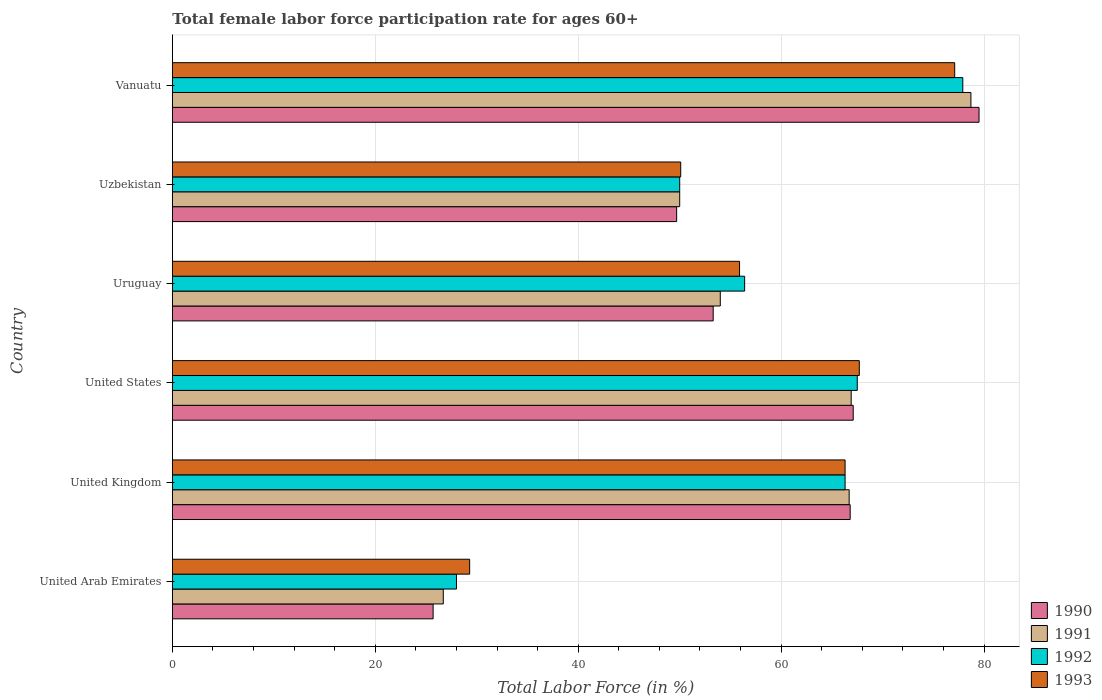How many different coloured bars are there?
Provide a short and direct response. 4. How many bars are there on the 6th tick from the top?
Your answer should be compact. 4. What is the label of the 3rd group of bars from the top?
Offer a very short reply. Uruguay. What is the female labor force participation rate in 1990 in United Arab Emirates?
Your response must be concise. 25.7. Across all countries, what is the maximum female labor force participation rate in 1992?
Your answer should be compact. 77.9. Across all countries, what is the minimum female labor force participation rate in 1991?
Offer a very short reply. 26.7. In which country was the female labor force participation rate in 1992 maximum?
Provide a short and direct response. Vanuatu. In which country was the female labor force participation rate in 1990 minimum?
Offer a terse response. United Arab Emirates. What is the total female labor force participation rate in 1992 in the graph?
Keep it short and to the point. 346.1. What is the difference between the female labor force participation rate in 1990 in United Arab Emirates and that in Vanuatu?
Your answer should be very brief. -53.8. What is the difference between the female labor force participation rate in 1990 in United States and the female labor force participation rate in 1993 in United Arab Emirates?
Your response must be concise. 37.8. What is the average female labor force participation rate in 1991 per country?
Offer a terse response. 57.17. What is the difference between the female labor force participation rate in 1990 and female labor force participation rate in 1993 in Uzbekistan?
Your response must be concise. -0.4. In how many countries, is the female labor force participation rate in 1991 greater than 24 %?
Offer a terse response. 6. What is the ratio of the female labor force participation rate in 1993 in United States to that in Uzbekistan?
Give a very brief answer. 1.35. Is the female labor force participation rate in 1993 in United Kingdom less than that in United States?
Give a very brief answer. Yes. Is the difference between the female labor force participation rate in 1990 in United Arab Emirates and Uzbekistan greater than the difference between the female labor force participation rate in 1993 in United Arab Emirates and Uzbekistan?
Make the answer very short. No. What is the difference between the highest and the second highest female labor force participation rate in 1991?
Ensure brevity in your answer.  11.8. What is the difference between the highest and the lowest female labor force participation rate in 1991?
Keep it short and to the point. 52. In how many countries, is the female labor force participation rate in 1993 greater than the average female labor force participation rate in 1993 taken over all countries?
Your response must be concise. 3. Is it the case that in every country, the sum of the female labor force participation rate in 1992 and female labor force participation rate in 1990 is greater than the sum of female labor force participation rate in 1993 and female labor force participation rate in 1991?
Your answer should be very brief. No. How many bars are there?
Make the answer very short. 24. How many countries are there in the graph?
Give a very brief answer. 6. What is the difference between two consecutive major ticks on the X-axis?
Your answer should be compact. 20. Does the graph contain any zero values?
Provide a short and direct response. No. Where does the legend appear in the graph?
Your response must be concise. Bottom right. How many legend labels are there?
Offer a terse response. 4. What is the title of the graph?
Your response must be concise. Total female labor force participation rate for ages 60+. What is the label or title of the X-axis?
Your answer should be compact. Total Labor Force (in %). What is the label or title of the Y-axis?
Give a very brief answer. Country. What is the Total Labor Force (in %) of 1990 in United Arab Emirates?
Your response must be concise. 25.7. What is the Total Labor Force (in %) of 1991 in United Arab Emirates?
Offer a terse response. 26.7. What is the Total Labor Force (in %) in 1993 in United Arab Emirates?
Your response must be concise. 29.3. What is the Total Labor Force (in %) of 1990 in United Kingdom?
Ensure brevity in your answer.  66.8. What is the Total Labor Force (in %) of 1991 in United Kingdom?
Keep it short and to the point. 66.7. What is the Total Labor Force (in %) of 1992 in United Kingdom?
Keep it short and to the point. 66.3. What is the Total Labor Force (in %) in 1993 in United Kingdom?
Give a very brief answer. 66.3. What is the Total Labor Force (in %) in 1990 in United States?
Provide a short and direct response. 67.1. What is the Total Labor Force (in %) in 1991 in United States?
Your answer should be very brief. 66.9. What is the Total Labor Force (in %) of 1992 in United States?
Ensure brevity in your answer.  67.5. What is the Total Labor Force (in %) of 1993 in United States?
Give a very brief answer. 67.7. What is the Total Labor Force (in %) in 1990 in Uruguay?
Keep it short and to the point. 53.3. What is the Total Labor Force (in %) in 1991 in Uruguay?
Make the answer very short. 54. What is the Total Labor Force (in %) of 1992 in Uruguay?
Provide a short and direct response. 56.4. What is the Total Labor Force (in %) in 1993 in Uruguay?
Your response must be concise. 55.9. What is the Total Labor Force (in %) of 1990 in Uzbekistan?
Provide a succinct answer. 49.7. What is the Total Labor Force (in %) in 1991 in Uzbekistan?
Your response must be concise. 50. What is the Total Labor Force (in %) of 1993 in Uzbekistan?
Give a very brief answer. 50.1. What is the Total Labor Force (in %) of 1990 in Vanuatu?
Ensure brevity in your answer.  79.5. What is the Total Labor Force (in %) of 1991 in Vanuatu?
Give a very brief answer. 78.7. What is the Total Labor Force (in %) of 1992 in Vanuatu?
Your answer should be very brief. 77.9. What is the Total Labor Force (in %) in 1993 in Vanuatu?
Ensure brevity in your answer.  77.1. Across all countries, what is the maximum Total Labor Force (in %) of 1990?
Provide a succinct answer. 79.5. Across all countries, what is the maximum Total Labor Force (in %) in 1991?
Offer a very short reply. 78.7. Across all countries, what is the maximum Total Labor Force (in %) in 1992?
Keep it short and to the point. 77.9. Across all countries, what is the maximum Total Labor Force (in %) in 1993?
Provide a succinct answer. 77.1. Across all countries, what is the minimum Total Labor Force (in %) of 1990?
Make the answer very short. 25.7. Across all countries, what is the minimum Total Labor Force (in %) of 1991?
Your answer should be very brief. 26.7. Across all countries, what is the minimum Total Labor Force (in %) in 1993?
Offer a terse response. 29.3. What is the total Total Labor Force (in %) of 1990 in the graph?
Provide a short and direct response. 342.1. What is the total Total Labor Force (in %) of 1991 in the graph?
Your response must be concise. 343. What is the total Total Labor Force (in %) in 1992 in the graph?
Your answer should be very brief. 346.1. What is the total Total Labor Force (in %) of 1993 in the graph?
Provide a succinct answer. 346.4. What is the difference between the Total Labor Force (in %) in 1990 in United Arab Emirates and that in United Kingdom?
Your answer should be compact. -41.1. What is the difference between the Total Labor Force (in %) in 1991 in United Arab Emirates and that in United Kingdom?
Provide a short and direct response. -40. What is the difference between the Total Labor Force (in %) of 1992 in United Arab Emirates and that in United Kingdom?
Offer a terse response. -38.3. What is the difference between the Total Labor Force (in %) in 1993 in United Arab Emirates and that in United Kingdom?
Give a very brief answer. -37. What is the difference between the Total Labor Force (in %) in 1990 in United Arab Emirates and that in United States?
Keep it short and to the point. -41.4. What is the difference between the Total Labor Force (in %) in 1991 in United Arab Emirates and that in United States?
Offer a very short reply. -40.2. What is the difference between the Total Labor Force (in %) in 1992 in United Arab Emirates and that in United States?
Your response must be concise. -39.5. What is the difference between the Total Labor Force (in %) in 1993 in United Arab Emirates and that in United States?
Offer a very short reply. -38.4. What is the difference between the Total Labor Force (in %) of 1990 in United Arab Emirates and that in Uruguay?
Your answer should be very brief. -27.6. What is the difference between the Total Labor Force (in %) in 1991 in United Arab Emirates and that in Uruguay?
Ensure brevity in your answer.  -27.3. What is the difference between the Total Labor Force (in %) of 1992 in United Arab Emirates and that in Uruguay?
Ensure brevity in your answer.  -28.4. What is the difference between the Total Labor Force (in %) in 1993 in United Arab Emirates and that in Uruguay?
Make the answer very short. -26.6. What is the difference between the Total Labor Force (in %) in 1991 in United Arab Emirates and that in Uzbekistan?
Your response must be concise. -23.3. What is the difference between the Total Labor Force (in %) of 1993 in United Arab Emirates and that in Uzbekistan?
Your answer should be very brief. -20.8. What is the difference between the Total Labor Force (in %) in 1990 in United Arab Emirates and that in Vanuatu?
Make the answer very short. -53.8. What is the difference between the Total Labor Force (in %) in 1991 in United Arab Emirates and that in Vanuatu?
Your answer should be compact. -52. What is the difference between the Total Labor Force (in %) in 1992 in United Arab Emirates and that in Vanuatu?
Your answer should be very brief. -49.9. What is the difference between the Total Labor Force (in %) of 1993 in United Arab Emirates and that in Vanuatu?
Offer a terse response. -47.8. What is the difference between the Total Labor Force (in %) of 1990 in United Kingdom and that in United States?
Your answer should be compact. -0.3. What is the difference between the Total Labor Force (in %) in 1992 in United Kingdom and that in United States?
Ensure brevity in your answer.  -1.2. What is the difference between the Total Labor Force (in %) in 1993 in United Kingdom and that in United States?
Provide a succinct answer. -1.4. What is the difference between the Total Labor Force (in %) of 1990 in United Kingdom and that in Uruguay?
Make the answer very short. 13.5. What is the difference between the Total Labor Force (in %) of 1991 in United Kingdom and that in Uruguay?
Make the answer very short. 12.7. What is the difference between the Total Labor Force (in %) of 1992 in United Kingdom and that in Uruguay?
Your answer should be very brief. 9.9. What is the difference between the Total Labor Force (in %) of 1993 in United Kingdom and that in Uruguay?
Your answer should be compact. 10.4. What is the difference between the Total Labor Force (in %) of 1990 in United Kingdom and that in Uzbekistan?
Provide a succinct answer. 17.1. What is the difference between the Total Labor Force (in %) in 1991 in United Kingdom and that in Uzbekistan?
Your answer should be compact. 16.7. What is the difference between the Total Labor Force (in %) in 1992 in United Kingdom and that in Uzbekistan?
Give a very brief answer. 16.3. What is the difference between the Total Labor Force (in %) in 1993 in United Kingdom and that in Uzbekistan?
Your answer should be compact. 16.2. What is the difference between the Total Labor Force (in %) of 1991 in United Kingdom and that in Vanuatu?
Ensure brevity in your answer.  -12. What is the difference between the Total Labor Force (in %) in 1992 in United Kingdom and that in Vanuatu?
Offer a terse response. -11.6. What is the difference between the Total Labor Force (in %) in 1991 in United States and that in Uruguay?
Your answer should be very brief. 12.9. What is the difference between the Total Labor Force (in %) in 1990 in United States and that in Uzbekistan?
Offer a very short reply. 17.4. What is the difference between the Total Labor Force (in %) of 1992 in United States and that in Uzbekistan?
Provide a short and direct response. 17.5. What is the difference between the Total Labor Force (in %) of 1993 in United States and that in Vanuatu?
Provide a succinct answer. -9.4. What is the difference between the Total Labor Force (in %) in 1991 in Uruguay and that in Uzbekistan?
Give a very brief answer. 4. What is the difference between the Total Labor Force (in %) in 1990 in Uruguay and that in Vanuatu?
Provide a short and direct response. -26.2. What is the difference between the Total Labor Force (in %) in 1991 in Uruguay and that in Vanuatu?
Provide a short and direct response. -24.7. What is the difference between the Total Labor Force (in %) in 1992 in Uruguay and that in Vanuatu?
Your answer should be compact. -21.5. What is the difference between the Total Labor Force (in %) of 1993 in Uruguay and that in Vanuatu?
Ensure brevity in your answer.  -21.2. What is the difference between the Total Labor Force (in %) of 1990 in Uzbekistan and that in Vanuatu?
Provide a short and direct response. -29.8. What is the difference between the Total Labor Force (in %) in 1991 in Uzbekistan and that in Vanuatu?
Make the answer very short. -28.7. What is the difference between the Total Labor Force (in %) in 1992 in Uzbekistan and that in Vanuatu?
Your response must be concise. -27.9. What is the difference between the Total Labor Force (in %) of 1993 in Uzbekistan and that in Vanuatu?
Ensure brevity in your answer.  -27. What is the difference between the Total Labor Force (in %) in 1990 in United Arab Emirates and the Total Labor Force (in %) in 1991 in United Kingdom?
Your response must be concise. -41. What is the difference between the Total Labor Force (in %) in 1990 in United Arab Emirates and the Total Labor Force (in %) in 1992 in United Kingdom?
Your response must be concise. -40.6. What is the difference between the Total Labor Force (in %) in 1990 in United Arab Emirates and the Total Labor Force (in %) in 1993 in United Kingdom?
Give a very brief answer. -40.6. What is the difference between the Total Labor Force (in %) of 1991 in United Arab Emirates and the Total Labor Force (in %) of 1992 in United Kingdom?
Offer a terse response. -39.6. What is the difference between the Total Labor Force (in %) in 1991 in United Arab Emirates and the Total Labor Force (in %) in 1993 in United Kingdom?
Offer a very short reply. -39.6. What is the difference between the Total Labor Force (in %) of 1992 in United Arab Emirates and the Total Labor Force (in %) of 1993 in United Kingdom?
Ensure brevity in your answer.  -38.3. What is the difference between the Total Labor Force (in %) in 1990 in United Arab Emirates and the Total Labor Force (in %) in 1991 in United States?
Offer a terse response. -41.2. What is the difference between the Total Labor Force (in %) of 1990 in United Arab Emirates and the Total Labor Force (in %) of 1992 in United States?
Ensure brevity in your answer.  -41.8. What is the difference between the Total Labor Force (in %) in 1990 in United Arab Emirates and the Total Labor Force (in %) in 1993 in United States?
Your answer should be very brief. -42. What is the difference between the Total Labor Force (in %) in 1991 in United Arab Emirates and the Total Labor Force (in %) in 1992 in United States?
Offer a terse response. -40.8. What is the difference between the Total Labor Force (in %) in 1991 in United Arab Emirates and the Total Labor Force (in %) in 1993 in United States?
Your answer should be compact. -41. What is the difference between the Total Labor Force (in %) of 1992 in United Arab Emirates and the Total Labor Force (in %) of 1993 in United States?
Your answer should be compact. -39.7. What is the difference between the Total Labor Force (in %) of 1990 in United Arab Emirates and the Total Labor Force (in %) of 1991 in Uruguay?
Make the answer very short. -28.3. What is the difference between the Total Labor Force (in %) of 1990 in United Arab Emirates and the Total Labor Force (in %) of 1992 in Uruguay?
Your response must be concise. -30.7. What is the difference between the Total Labor Force (in %) in 1990 in United Arab Emirates and the Total Labor Force (in %) in 1993 in Uruguay?
Your answer should be very brief. -30.2. What is the difference between the Total Labor Force (in %) in 1991 in United Arab Emirates and the Total Labor Force (in %) in 1992 in Uruguay?
Provide a succinct answer. -29.7. What is the difference between the Total Labor Force (in %) of 1991 in United Arab Emirates and the Total Labor Force (in %) of 1993 in Uruguay?
Give a very brief answer. -29.2. What is the difference between the Total Labor Force (in %) in 1992 in United Arab Emirates and the Total Labor Force (in %) in 1993 in Uruguay?
Provide a succinct answer. -27.9. What is the difference between the Total Labor Force (in %) of 1990 in United Arab Emirates and the Total Labor Force (in %) of 1991 in Uzbekistan?
Provide a succinct answer. -24.3. What is the difference between the Total Labor Force (in %) in 1990 in United Arab Emirates and the Total Labor Force (in %) in 1992 in Uzbekistan?
Your answer should be very brief. -24.3. What is the difference between the Total Labor Force (in %) of 1990 in United Arab Emirates and the Total Labor Force (in %) of 1993 in Uzbekistan?
Provide a succinct answer. -24.4. What is the difference between the Total Labor Force (in %) of 1991 in United Arab Emirates and the Total Labor Force (in %) of 1992 in Uzbekistan?
Your answer should be compact. -23.3. What is the difference between the Total Labor Force (in %) in 1991 in United Arab Emirates and the Total Labor Force (in %) in 1993 in Uzbekistan?
Your answer should be very brief. -23.4. What is the difference between the Total Labor Force (in %) in 1992 in United Arab Emirates and the Total Labor Force (in %) in 1993 in Uzbekistan?
Give a very brief answer. -22.1. What is the difference between the Total Labor Force (in %) of 1990 in United Arab Emirates and the Total Labor Force (in %) of 1991 in Vanuatu?
Offer a very short reply. -53. What is the difference between the Total Labor Force (in %) of 1990 in United Arab Emirates and the Total Labor Force (in %) of 1992 in Vanuatu?
Offer a very short reply. -52.2. What is the difference between the Total Labor Force (in %) of 1990 in United Arab Emirates and the Total Labor Force (in %) of 1993 in Vanuatu?
Your answer should be very brief. -51.4. What is the difference between the Total Labor Force (in %) of 1991 in United Arab Emirates and the Total Labor Force (in %) of 1992 in Vanuatu?
Ensure brevity in your answer.  -51.2. What is the difference between the Total Labor Force (in %) of 1991 in United Arab Emirates and the Total Labor Force (in %) of 1993 in Vanuatu?
Offer a terse response. -50.4. What is the difference between the Total Labor Force (in %) of 1992 in United Arab Emirates and the Total Labor Force (in %) of 1993 in Vanuatu?
Your answer should be very brief. -49.1. What is the difference between the Total Labor Force (in %) of 1990 in United Kingdom and the Total Labor Force (in %) of 1992 in United States?
Your response must be concise. -0.7. What is the difference between the Total Labor Force (in %) in 1990 in United Kingdom and the Total Labor Force (in %) in 1993 in United States?
Provide a short and direct response. -0.9. What is the difference between the Total Labor Force (in %) in 1992 in United Kingdom and the Total Labor Force (in %) in 1993 in United States?
Your answer should be very brief. -1.4. What is the difference between the Total Labor Force (in %) in 1990 in United Kingdom and the Total Labor Force (in %) in 1992 in Uruguay?
Your answer should be very brief. 10.4. What is the difference between the Total Labor Force (in %) of 1990 in United Kingdom and the Total Labor Force (in %) of 1993 in Uruguay?
Offer a very short reply. 10.9. What is the difference between the Total Labor Force (in %) in 1991 in United Kingdom and the Total Labor Force (in %) in 1992 in Uruguay?
Provide a short and direct response. 10.3. What is the difference between the Total Labor Force (in %) in 1991 in United Kingdom and the Total Labor Force (in %) in 1993 in Uruguay?
Keep it short and to the point. 10.8. What is the difference between the Total Labor Force (in %) of 1990 in United Kingdom and the Total Labor Force (in %) of 1991 in Uzbekistan?
Your answer should be compact. 16.8. What is the difference between the Total Labor Force (in %) of 1990 in United Kingdom and the Total Labor Force (in %) of 1993 in Uzbekistan?
Offer a terse response. 16.7. What is the difference between the Total Labor Force (in %) in 1991 in United Kingdom and the Total Labor Force (in %) in 1993 in Uzbekistan?
Offer a very short reply. 16.6. What is the difference between the Total Labor Force (in %) in 1992 in United Kingdom and the Total Labor Force (in %) in 1993 in Uzbekistan?
Give a very brief answer. 16.2. What is the difference between the Total Labor Force (in %) in 1990 in United Kingdom and the Total Labor Force (in %) in 1991 in Vanuatu?
Your answer should be very brief. -11.9. What is the difference between the Total Labor Force (in %) of 1992 in United Kingdom and the Total Labor Force (in %) of 1993 in Vanuatu?
Offer a very short reply. -10.8. What is the difference between the Total Labor Force (in %) of 1990 in United States and the Total Labor Force (in %) of 1991 in Uruguay?
Make the answer very short. 13.1. What is the difference between the Total Labor Force (in %) in 1990 in United States and the Total Labor Force (in %) in 1992 in Uruguay?
Your answer should be very brief. 10.7. What is the difference between the Total Labor Force (in %) in 1990 in United States and the Total Labor Force (in %) in 1993 in Uruguay?
Your answer should be very brief. 11.2. What is the difference between the Total Labor Force (in %) of 1991 in United States and the Total Labor Force (in %) of 1992 in Uruguay?
Ensure brevity in your answer.  10.5. What is the difference between the Total Labor Force (in %) in 1991 in United States and the Total Labor Force (in %) in 1993 in Uruguay?
Make the answer very short. 11. What is the difference between the Total Labor Force (in %) of 1990 in United States and the Total Labor Force (in %) of 1993 in Uzbekistan?
Provide a succinct answer. 17. What is the difference between the Total Labor Force (in %) in 1991 in United States and the Total Labor Force (in %) in 1992 in Uzbekistan?
Keep it short and to the point. 16.9. What is the difference between the Total Labor Force (in %) in 1991 in United States and the Total Labor Force (in %) in 1993 in Uzbekistan?
Make the answer very short. 16.8. What is the difference between the Total Labor Force (in %) in 1990 in United States and the Total Labor Force (in %) in 1993 in Vanuatu?
Make the answer very short. -10. What is the difference between the Total Labor Force (in %) in 1991 in United States and the Total Labor Force (in %) in 1992 in Vanuatu?
Ensure brevity in your answer.  -11. What is the difference between the Total Labor Force (in %) in 1991 in United States and the Total Labor Force (in %) in 1993 in Vanuatu?
Your answer should be very brief. -10.2. What is the difference between the Total Labor Force (in %) in 1991 in Uruguay and the Total Labor Force (in %) in 1993 in Uzbekistan?
Provide a short and direct response. 3.9. What is the difference between the Total Labor Force (in %) of 1992 in Uruguay and the Total Labor Force (in %) of 1993 in Uzbekistan?
Make the answer very short. 6.3. What is the difference between the Total Labor Force (in %) of 1990 in Uruguay and the Total Labor Force (in %) of 1991 in Vanuatu?
Ensure brevity in your answer.  -25.4. What is the difference between the Total Labor Force (in %) in 1990 in Uruguay and the Total Labor Force (in %) in 1992 in Vanuatu?
Offer a terse response. -24.6. What is the difference between the Total Labor Force (in %) in 1990 in Uruguay and the Total Labor Force (in %) in 1993 in Vanuatu?
Offer a very short reply. -23.8. What is the difference between the Total Labor Force (in %) in 1991 in Uruguay and the Total Labor Force (in %) in 1992 in Vanuatu?
Provide a succinct answer. -23.9. What is the difference between the Total Labor Force (in %) of 1991 in Uruguay and the Total Labor Force (in %) of 1993 in Vanuatu?
Offer a very short reply. -23.1. What is the difference between the Total Labor Force (in %) of 1992 in Uruguay and the Total Labor Force (in %) of 1993 in Vanuatu?
Your answer should be very brief. -20.7. What is the difference between the Total Labor Force (in %) of 1990 in Uzbekistan and the Total Labor Force (in %) of 1992 in Vanuatu?
Offer a terse response. -28.2. What is the difference between the Total Labor Force (in %) in 1990 in Uzbekistan and the Total Labor Force (in %) in 1993 in Vanuatu?
Keep it short and to the point. -27.4. What is the difference between the Total Labor Force (in %) of 1991 in Uzbekistan and the Total Labor Force (in %) of 1992 in Vanuatu?
Provide a short and direct response. -27.9. What is the difference between the Total Labor Force (in %) in 1991 in Uzbekistan and the Total Labor Force (in %) in 1993 in Vanuatu?
Make the answer very short. -27.1. What is the difference between the Total Labor Force (in %) in 1992 in Uzbekistan and the Total Labor Force (in %) in 1993 in Vanuatu?
Your answer should be very brief. -27.1. What is the average Total Labor Force (in %) of 1990 per country?
Keep it short and to the point. 57.02. What is the average Total Labor Force (in %) of 1991 per country?
Your answer should be very brief. 57.17. What is the average Total Labor Force (in %) in 1992 per country?
Your answer should be compact. 57.68. What is the average Total Labor Force (in %) in 1993 per country?
Make the answer very short. 57.73. What is the difference between the Total Labor Force (in %) of 1990 and Total Labor Force (in %) of 1991 in United Arab Emirates?
Ensure brevity in your answer.  -1. What is the difference between the Total Labor Force (in %) in 1990 and Total Labor Force (in %) in 1992 in United Arab Emirates?
Your answer should be very brief. -2.3. What is the difference between the Total Labor Force (in %) in 1991 and Total Labor Force (in %) in 1992 in United Arab Emirates?
Offer a very short reply. -1.3. What is the difference between the Total Labor Force (in %) of 1991 and Total Labor Force (in %) of 1993 in United Arab Emirates?
Provide a short and direct response. -2.6. What is the difference between the Total Labor Force (in %) of 1992 and Total Labor Force (in %) of 1993 in United Kingdom?
Ensure brevity in your answer.  0. What is the difference between the Total Labor Force (in %) of 1990 and Total Labor Force (in %) of 1991 in United States?
Ensure brevity in your answer.  0.2. What is the difference between the Total Labor Force (in %) in 1991 and Total Labor Force (in %) in 1992 in United States?
Your answer should be very brief. -0.6. What is the difference between the Total Labor Force (in %) of 1990 and Total Labor Force (in %) of 1991 in Uruguay?
Keep it short and to the point. -0.7. What is the difference between the Total Labor Force (in %) of 1992 and Total Labor Force (in %) of 1993 in Uruguay?
Provide a succinct answer. 0.5. What is the difference between the Total Labor Force (in %) of 1990 and Total Labor Force (in %) of 1991 in Uzbekistan?
Offer a terse response. -0.3. What is the difference between the Total Labor Force (in %) in 1991 and Total Labor Force (in %) in 1993 in Uzbekistan?
Provide a short and direct response. -0.1. What is the difference between the Total Labor Force (in %) of 1992 and Total Labor Force (in %) of 1993 in Uzbekistan?
Offer a terse response. -0.1. What is the difference between the Total Labor Force (in %) in 1990 and Total Labor Force (in %) in 1993 in Vanuatu?
Your answer should be very brief. 2.4. What is the difference between the Total Labor Force (in %) of 1992 and Total Labor Force (in %) of 1993 in Vanuatu?
Your response must be concise. 0.8. What is the ratio of the Total Labor Force (in %) of 1990 in United Arab Emirates to that in United Kingdom?
Keep it short and to the point. 0.38. What is the ratio of the Total Labor Force (in %) of 1991 in United Arab Emirates to that in United Kingdom?
Your response must be concise. 0.4. What is the ratio of the Total Labor Force (in %) in 1992 in United Arab Emirates to that in United Kingdom?
Give a very brief answer. 0.42. What is the ratio of the Total Labor Force (in %) of 1993 in United Arab Emirates to that in United Kingdom?
Offer a terse response. 0.44. What is the ratio of the Total Labor Force (in %) in 1990 in United Arab Emirates to that in United States?
Provide a short and direct response. 0.38. What is the ratio of the Total Labor Force (in %) of 1991 in United Arab Emirates to that in United States?
Your answer should be very brief. 0.4. What is the ratio of the Total Labor Force (in %) of 1992 in United Arab Emirates to that in United States?
Keep it short and to the point. 0.41. What is the ratio of the Total Labor Force (in %) in 1993 in United Arab Emirates to that in United States?
Provide a succinct answer. 0.43. What is the ratio of the Total Labor Force (in %) of 1990 in United Arab Emirates to that in Uruguay?
Offer a terse response. 0.48. What is the ratio of the Total Labor Force (in %) of 1991 in United Arab Emirates to that in Uruguay?
Your response must be concise. 0.49. What is the ratio of the Total Labor Force (in %) of 1992 in United Arab Emirates to that in Uruguay?
Make the answer very short. 0.5. What is the ratio of the Total Labor Force (in %) of 1993 in United Arab Emirates to that in Uruguay?
Provide a succinct answer. 0.52. What is the ratio of the Total Labor Force (in %) in 1990 in United Arab Emirates to that in Uzbekistan?
Give a very brief answer. 0.52. What is the ratio of the Total Labor Force (in %) in 1991 in United Arab Emirates to that in Uzbekistan?
Provide a short and direct response. 0.53. What is the ratio of the Total Labor Force (in %) in 1992 in United Arab Emirates to that in Uzbekistan?
Your answer should be compact. 0.56. What is the ratio of the Total Labor Force (in %) in 1993 in United Arab Emirates to that in Uzbekistan?
Your answer should be very brief. 0.58. What is the ratio of the Total Labor Force (in %) in 1990 in United Arab Emirates to that in Vanuatu?
Give a very brief answer. 0.32. What is the ratio of the Total Labor Force (in %) of 1991 in United Arab Emirates to that in Vanuatu?
Make the answer very short. 0.34. What is the ratio of the Total Labor Force (in %) in 1992 in United Arab Emirates to that in Vanuatu?
Offer a terse response. 0.36. What is the ratio of the Total Labor Force (in %) in 1993 in United Arab Emirates to that in Vanuatu?
Make the answer very short. 0.38. What is the ratio of the Total Labor Force (in %) in 1990 in United Kingdom to that in United States?
Your answer should be compact. 1. What is the ratio of the Total Labor Force (in %) in 1992 in United Kingdom to that in United States?
Offer a very short reply. 0.98. What is the ratio of the Total Labor Force (in %) of 1993 in United Kingdom to that in United States?
Offer a very short reply. 0.98. What is the ratio of the Total Labor Force (in %) in 1990 in United Kingdom to that in Uruguay?
Your answer should be very brief. 1.25. What is the ratio of the Total Labor Force (in %) in 1991 in United Kingdom to that in Uruguay?
Offer a very short reply. 1.24. What is the ratio of the Total Labor Force (in %) in 1992 in United Kingdom to that in Uruguay?
Your answer should be very brief. 1.18. What is the ratio of the Total Labor Force (in %) in 1993 in United Kingdom to that in Uruguay?
Offer a terse response. 1.19. What is the ratio of the Total Labor Force (in %) in 1990 in United Kingdom to that in Uzbekistan?
Offer a very short reply. 1.34. What is the ratio of the Total Labor Force (in %) of 1991 in United Kingdom to that in Uzbekistan?
Your answer should be compact. 1.33. What is the ratio of the Total Labor Force (in %) of 1992 in United Kingdom to that in Uzbekistan?
Your answer should be very brief. 1.33. What is the ratio of the Total Labor Force (in %) in 1993 in United Kingdom to that in Uzbekistan?
Offer a terse response. 1.32. What is the ratio of the Total Labor Force (in %) of 1990 in United Kingdom to that in Vanuatu?
Make the answer very short. 0.84. What is the ratio of the Total Labor Force (in %) in 1991 in United Kingdom to that in Vanuatu?
Your response must be concise. 0.85. What is the ratio of the Total Labor Force (in %) of 1992 in United Kingdom to that in Vanuatu?
Give a very brief answer. 0.85. What is the ratio of the Total Labor Force (in %) of 1993 in United Kingdom to that in Vanuatu?
Give a very brief answer. 0.86. What is the ratio of the Total Labor Force (in %) of 1990 in United States to that in Uruguay?
Provide a succinct answer. 1.26. What is the ratio of the Total Labor Force (in %) in 1991 in United States to that in Uruguay?
Ensure brevity in your answer.  1.24. What is the ratio of the Total Labor Force (in %) in 1992 in United States to that in Uruguay?
Make the answer very short. 1.2. What is the ratio of the Total Labor Force (in %) in 1993 in United States to that in Uruguay?
Provide a succinct answer. 1.21. What is the ratio of the Total Labor Force (in %) in 1990 in United States to that in Uzbekistan?
Offer a terse response. 1.35. What is the ratio of the Total Labor Force (in %) in 1991 in United States to that in Uzbekistan?
Your response must be concise. 1.34. What is the ratio of the Total Labor Force (in %) of 1992 in United States to that in Uzbekistan?
Offer a very short reply. 1.35. What is the ratio of the Total Labor Force (in %) in 1993 in United States to that in Uzbekistan?
Offer a very short reply. 1.35. What is the ratio of the Total Labor Force (in %) in 1990 in United States to that in Vanuatu?
Offer a very short reply. 0.84. What is the ratio of the Total Labor Force (in %) in 1991 in United States to that in Vanuatu?
Offer a terse response. 0.85. What is the ratio of the Total Labor Force (in %) in 1992 in United States to that in Vanuatu?
Offer a terse response. 0.87. What is the ratio of the Total Labor Force (in %) in 1993 in United States to that in Vanuatu?
Provide a succinct answer. 0.88. What is the ratio of the Total Labor Force (in %) of 1990 in Uruguay to that in Uzbekistan?
Your response must be concise. 1.07. What is the ratio of the Total Labor Force (in %) in 1992 in Uruguay to that in Uzbekistan?
Make the answer very short. 1.13. What is the ratio of the Total Labor Force (in %) in 1993 in Uruguay to that in Uzbekistan?
Give a very brief answer. 1.12. What is the ratio of the Total Labor Force (in %) in 1990 in Uruguay to that in Vanuatu?
Your response must be concise. 0.67. What is the ratio of the Total Labor Force (in %) in 1991 in Uruguay to that in Vanuatu?
Keep it short and to the point. 0.69. What is the ratio of the Total Labor Force (in %) of 1992 in Uruguay to that in Vanuatu?
Give a very brief answer. 0.72. What is the ratio of the Total Labor Force (in %) of 1993 in Uruguay to that in Vanuatu?
Offer a terse response. 0.72. What is the ratio of the Total Labor Force (in %) in 1990 in Uzbekistan to that in Vanuatu?
Provide a succinct answer. 0.63. What is the ratio of the Total Labor Force (in %) of 1991 in Uzbekistan to that in Vanuatu?
Keep it short and to the point. 0.64. What is the ratio of the Total Labor Force (in %) of 1992 in Uzbekistan to that in Vanuatu?
Your answer should be very brief. 0.64. What is the ratio of the Total Labor Force (in %) of 1993 in Uzbekistan to that in Vanuatu?
Your answer should be compact. 0.65. What is the difference between the highest and the second highest Total Labor Force (in %) of 1991?
Your answer should be compact. 11.8. What is the difference between the highest and the second highest Total Labor Force (in %) of 1993?
Offer a terse response. 9.4. What is the difference between the highest and the lowest Total Labor Force (in %) of 1990?
Your answer should be compact. 53.8. What is the difference between the highest and the lowest Total Labor Force (in %) in 1992?
Offer a very short reply. 49.9. What is the difference between the highest and the lowest Total Labor Force (in %) of 1993?
Your answer should be very brief. 47.8. 